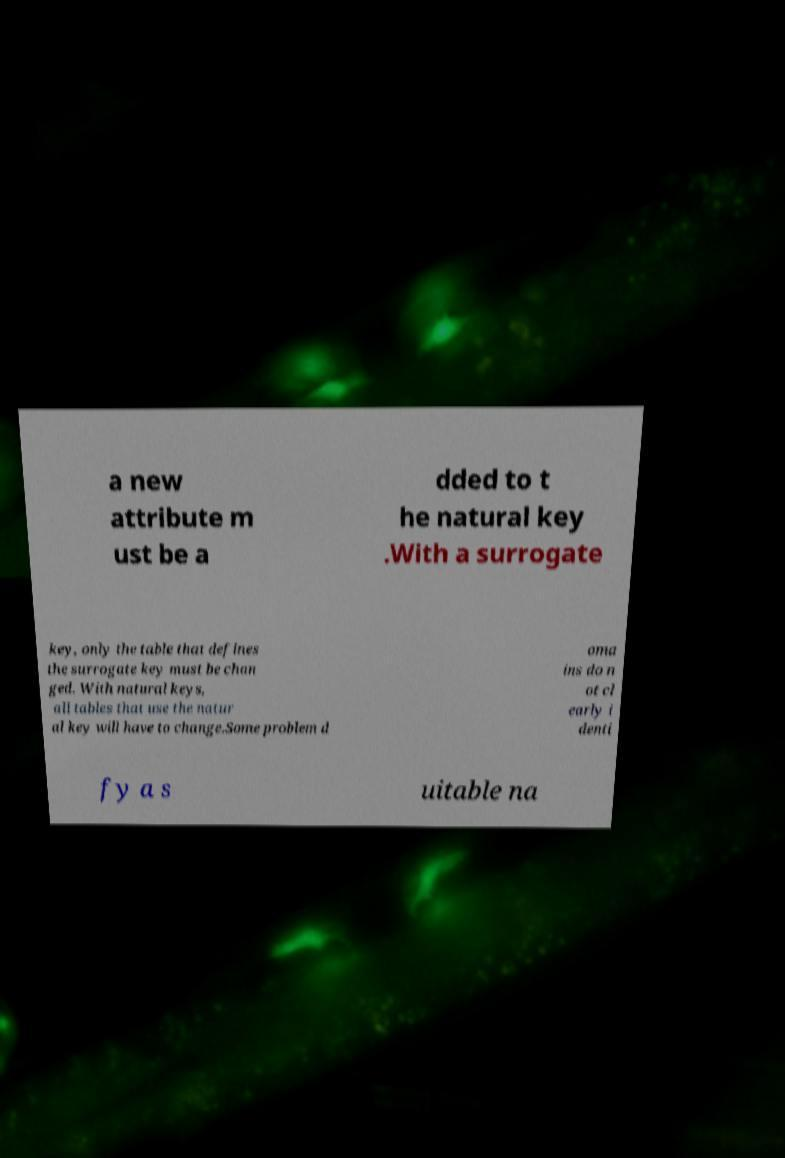Could you extract and type out the text from this image? a new attribute m ust be a dded to t he natural key .With a surrogate key, only the table that defines the surrogate key must be chan ged. With natural keys, all tables that use the natur al key will have to change.Some problem d oma ins do n ot cl early i denti fy a s uitable na 